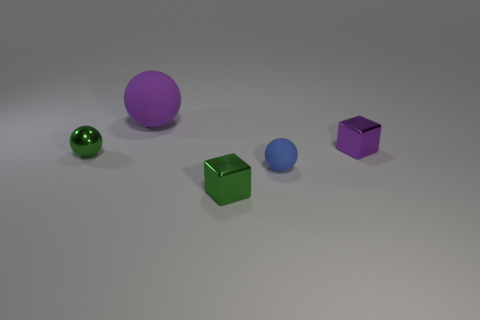Add 1 big matte spheres. How many objects exist? 6 Subtract all blocks. How many objects are left? 3 Add 1 large things. How many large things are left? 2 Add 5 small cubes. How many small cubes exist? 7 Subtract 1 green cubes. How many objects are left? 4 Subtract all large spheres. Subtract all tiny purple objects. How many objects are left? 3 